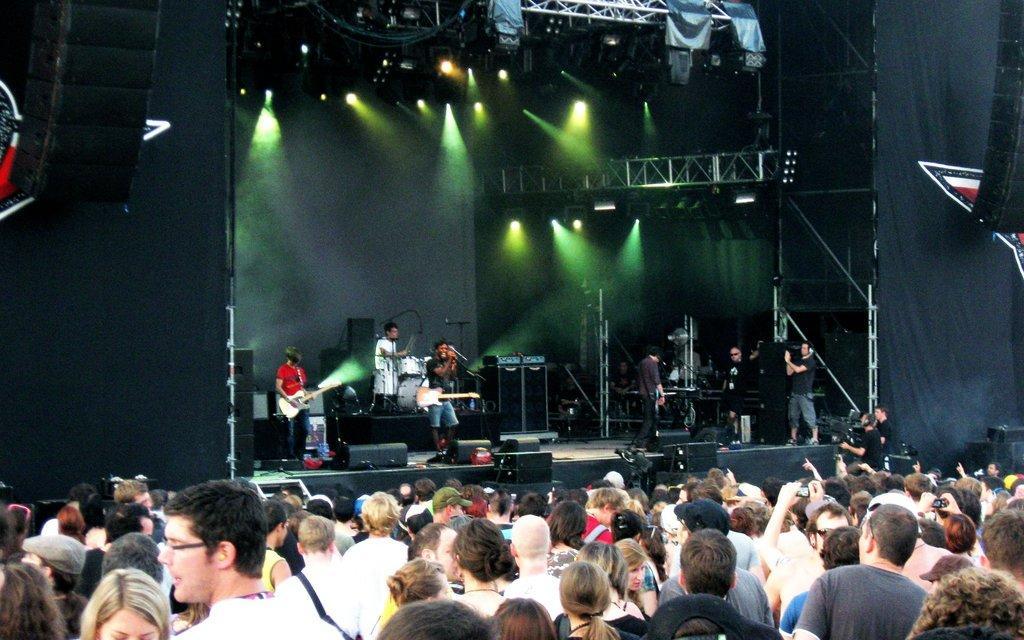Describe this image in one or two sentences. There are group of people standing and watching the performance. This looks like a stage show. There are people standing and playing musical instruments. These are the stage show lights which are green in color. At the top left corner of the image I can see a speaker. 